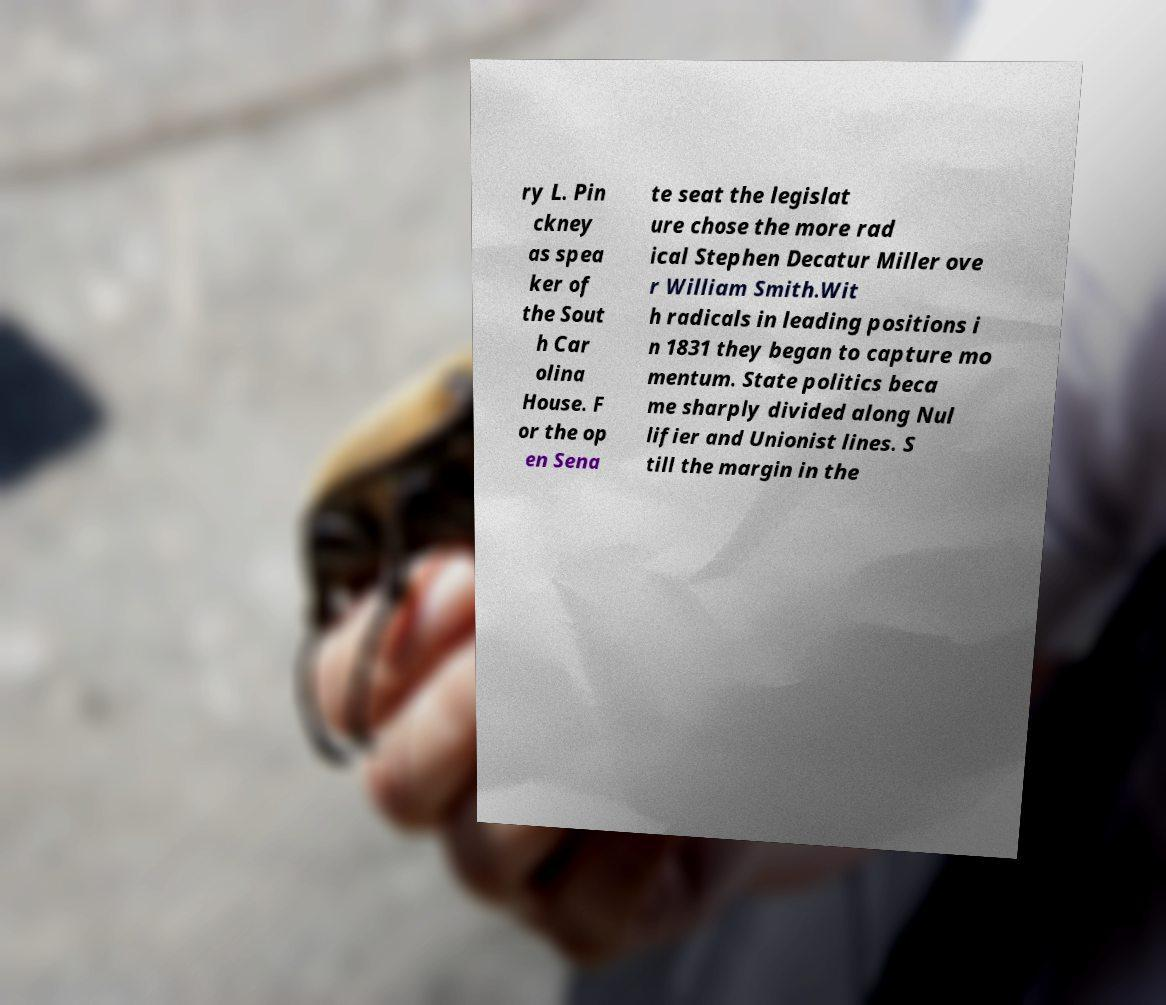Could you extract and type out the text from this image? ry L. Pin ckney as spea ker of the Sout h Car olina House. F or the op en Sena te seat the legislat ure chose the more rad ical Stephen Decatur Miller ove r William Smith.Wit h radicals in leading positions i n 1831 they began to capture mo mentum. State politics beca me sharply divided along Nul lifier and Unionist lines. S till the margin in the 